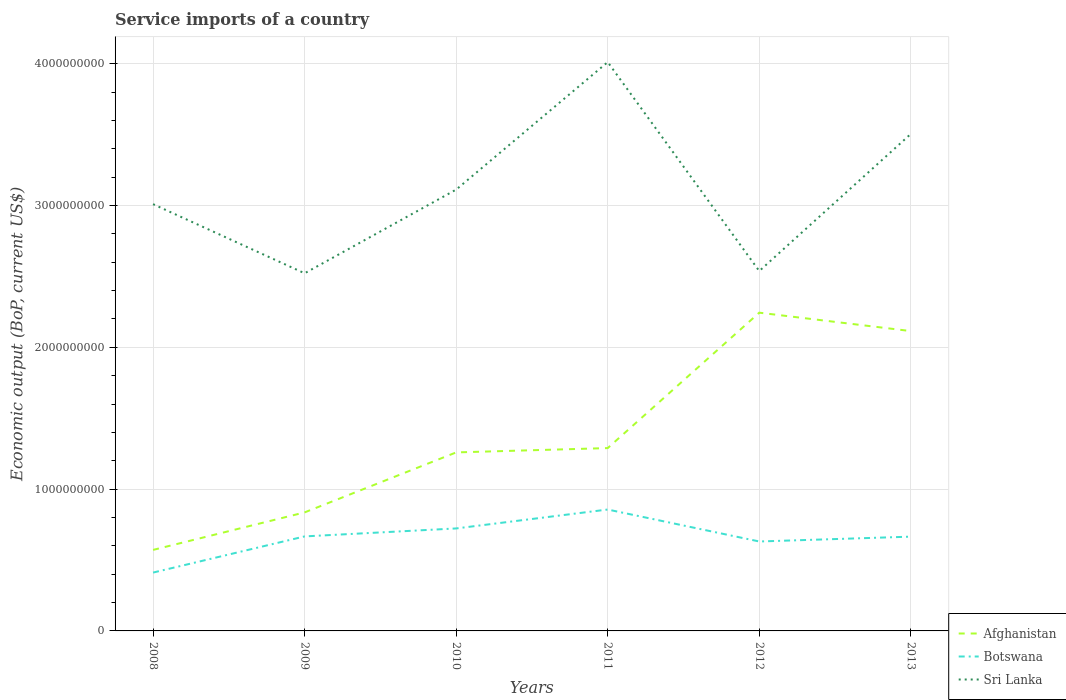How many different coloured lines are there?
Provide a short and direct response. 3. Across all years, what is the maximum service imports in Sri Lanka?
Provide a short and direct response. 2.52e+09. In which year was the service imports in Botswana maximum?
Your response must be concise. 2008. What is the total service imports in Botswana in the graph?
Give a very brief answer. 1.67e+06. What is the difference between the highest and the second highest service imports in Sri Lanka?
Ensure brevity in your answer.  1.49e+09. What is the difference between the highest and the lowest service imports in Botswana?
Ensure brevity in your answer.  4. How many lines are there?
Ensure brevity in your answer.  3. Does the graph contain grids?
Offer a terse response. Yes. How many legend labels are there?
Your answer should be compact. 3. How are the legend labels stacked?
Your response must be concise. Vertical. What is the title of the graph?
Offer a terse response. Service imports of a country. What is the label or title of the X-axis?
Provide a short and direct response. Years. What is the label or title of the Y-axis?
Your answer should be very brief. Economic output (BoP, current US$). What is the Economic output (BoP, current US$) of Afghanistan in 2008?
Offer a terse response. 5.71e+08. What is the Economic output (BoP, current US$) in Botswana in 2008?
Your response must be concise. 4.12e+08. What is the Economic output (BoP, current US$) of Sri Lanka in 2008?
Offer a terse response. 3.01e+09. What is the Economic output (BoP, current US$) of Afghanistan in 2009?
Make the answer very short. 8.36e+08. What is the Economic output (BoP, current US$) in Botswana in 2009?
Your answer should be compact. 6.67e+08. What is the Economic output (BoP, current US$) in Sri Lanka in 2009?
Keep it short and to the point. 2.52e+09. What is the Economic output (BoP, current US$) in Afghanistan in 2010?
Make the answer very short. 1.26e+09. What is the Economic output (BoP, current US$) in Botswana in 2010?
Your answer should be compact. 7.23e+08. What is the Economic output (BoP, current US$) in Sri Lanka in 2010?
Provide a succinct answer. 3.11e+09. What is the Economic output (BoP, current US$) in Afghanistan in 2011?
Ensure brevity in your answer.  1.29e+09. What is the Economic output (BoP, current US$) in Botswana in 2011?
Give a very brief answer. 8.56e+08. What is the Economic output (BoP, current US$) in Sri Lanka in 2011?
Make the answer very short. 4.01e+09. What is the Economic output (BoP, current US$) in Afghanistan in 2012?
Offer a terse response. 2.24e+09. What is the Economic output (BoP, current US$) of Botswana in 2012?
Keep it short and to the point. 6.31e+08. What is the Economic output (BoP, current US$) in Sri Lanka in 2012?
Give a very brief answer. 2.54e+09. What is the Economic output (BoP, current US$) of Afghanistan in 2013?
Your answer should be very brief. 2.11e+09. What is the Economic output (BoP, current US$) in Botswana in 2013?
Your response must be concise. 6.65e+08. What is the Economic output (BoP, current US$) in Sri Lanka in 2013?
Provide a short and direct response. 3.51e+09. Across all years, what is the maximum Economic output (BoP, current US$) in Afghanistan?
Provide a succinct answer. 2.24e+09. Across all years, what is the maximum Economic output (BoP, current US$) in Botswana?
Provide a succinct answer. 8.56e+08. Across all years, what is the maximum Economic output (BoP, current US$) of Sri Lanka?
Provide a succinct answer. 4.01e+09. Across all years, what is the minimum Economic output (BoP, current US$) of Afghanistan?
Give a very brief answer. 5.71e+08. Across all years, what is the minimum Economic output (BoP, current US$) in Botswana?
Your answer should be compact. 4.12e+08. Across all years, what is the minimum Economic output (BoP, current US$) of Sri Lanka?
Ensure brevity in your answer.  2.52e+09. What is the total Economic output (BoP, current US$) in Afghanistan in the graph?
Your answer should be compact. 8.32e+09. What is the total Economic output (BoP, current US$) of Botswana in the graph?
Ensure brevity in your answer.  3.95e+09. What is the total Economic output (BoP, current US$) in Sri Lanka in the graph?
Ensure brevity in your answer.  1.87e+1. What is the difference between the Economic output (BoP, current US$) of Afghanistan in 2008 and that in 2009?
Keep it short and to the point. -2.65e+08. What is the difference between the Economic output (BoP, current US$) in Botswana in 2008 and that in 2009?
Your answer should be very brief. -2.55e+08. What is the difference between the Economic output (BoP, current US$) in Sri Lanka in 2008 and that in 2009?
Make the answer very short. 4.87e+08. What is the difference between the Economic output (BoP, current US$) in Afghanistan in 2008 and that in 2010?
Give a very brief answer. -6.88e+08. What is the difference between the Economic output (BoP, current US$) of Botswana in 2008 and that in 2010?
Your response must be concise. -3.11e+08. What is the difference between the Economic output (BoP, current US$) of Sri Lanka in 2008 and that in 2010?
Give a very brief answer. -1.03e+08. What is the difference between the Economic output (BoP, current US$) in Afghanistan in 2008 and that in 2011?
Your answer should be very brief. -7.18e+08. What is the difference between the Economic output (BoP, current US$) of Botswana in 2008 and that in 2011?
Make the answer very short. -4.45e+08. What is the difference between the Economic output (BoP, current US$) of Sri Lanka in 2008 and that in 2011?
Provide a succinct answer. -1.00e+09. What is the difference between the Economic output (BoP, current US$) in Afghanistan in 2008 and that in 2012?
Provide a short and direct response. -1.67e+09. What is the difference between the Economic output (BoP, current US$) in Botswana in 2008 and that in 2012?
Your response must be concise. -2.19e+08. What is the difference between the Economic output (BoP, current US$) of Sri Lanka in 2008 and that in 2012?
Provide a short and direct response. 4.72e+08. What is the difference between the Economic output (BoP, current US$) in Afghanistan in 2008 and that in 2013?
Ensure brevity in your answer.  -1.54e+09. What is the difference between the Economic output (BoP, current US$) of Botswana in 2008 and that in 2013?
Provide a succinct answer. -2.53e+08. What is the difference between the Economic output (BoP, current US$) of Sri Lanka in 2008 and that in 2013?
Provide a succinct answer. -4.95e+08. What is the difference between the Economic output (BoP, current US$) of Afghanistan in 2009 and that in 2010?
Your response must be concise. -4.23e+08. What is the difference between the Economic output (BoP, current US$) of Botswana in 2009 and that in 2010?
Provide a succinct answer. -5.62e+07. What is the difference between the Economic output (BoP, current US$) of Sri Lanka in 2009 and that in 2010?
Offer a very short reply. -5.90e+08. What is the difference between the Economic output (BoP, current US$) in Afghanistan in 2009 and that in 2011?
Provide a short and direct response. -4.54e+08. What is the difference between the Economic output (BoP, current US$) of Botswana in 2009 and that in 2011?
Your answer should be very brief. -1.90e+08. What is the difference between the Economic output (BoP, current US$) in Sri Lanka in 2009 and that in 2011?
Provide a succinct answer. -1.49e+09. What is the difference between the Economic output (BoP, current US$) in Afghanistan in 2009 and that in 2012?
Provide a short and direct response. -1.41e+09. What is the difference between the Economic output (BoP, current US$) in Botswana in 2009 and that in 2012?
Your answer should be very brief. 3.58e+07. What is the difference between the Economic output (BoP, current US$) of Sri Lanka in 2009 and that in 2012?
Provide a succinct answer. -1.60e+07. What is the difference between the Economic output (BoP, current US$) of Afghanistan in 2009 and that in 2013?
Ensure brevity in your answer.  -1.28e+09. What is the difference between the Economic output (BoP, current US$) of Botswana in 2009 and that in 2013?
Offer a terse response. 1.67e+06. What is the difference between the Economic output (BoP, current US$) in Sri Lanka in 2009 and that in 2013?
Ensure brevity in your answer.  -9.83e+08. What is the difference between the Economic output (BoP, current US$) in Afghanistan in 2010 and that in 2011?
Offer a terse response. -3.05e+07. What is the difference between the Economic output (BoP, current US$) of Botswana in 2010 and that in 2011?
Offer a terse response. -1.33e+08. What is the difference between the Economic output (BoP, current US$) in Sri Lanka in 2010 and that in 2011?
Provide a succinct answer. -8.99e+08. What is the difference between the Economic output (BoP, current US$) in Afghanistan in 2010 and that in 2012?
Ensure brevity in your answer.  -9.86e+08. What is the difference between the Economic output (BoP, current US$) in Botswana in 2010 and that in 2012?
Make the answer very short. 9.21e+07. What is the difference between the Economic output (BoP, current US$) in Sri Lanka in 2010 and that in 2012?
Your response must be concise. 5.74e+08. What is the difference between the Economic output (BoP, current US$) in Afghanistan in 2010 and that in 2013?
Make the answer very short. -8.56e+08. What is the difference between the Economic output (BoP, current US$) of Botswana in 2010 and that in 2013?
Ensure brevity in your answer.  5.79e+07. What is the difference between the Economic output (BoP, current US$) of Sri Lanka in 2010 and that in 2013?
Ensure brevity in your answer.  -3.93e+08. What is the difference between the Economic output (BoP, current US$) in Afghanistan in 2011 and that in 2012?
Make the answer very short. -9.55e+08. What is the difference between the Economic output (BoP, current US$) in Botswana in 2011 and that in 2012?
Your answer should be very brief. 2.25e+08. What is the difference between the Economic output (BoP, current US$) in Sri Lanka in 2011 and that in 2012?
Offer a very short reply. 1.47e+09. What is the difference between the Economic output (BoP, current US$) of Afghanistan in 2011 and that in 2013?
Make the answer very short. -8.25e+08. What is the difference between the Economic output (BoP, current US$) in Botswana in 2011 and that in 2013?
Offer a terse response. 1.91e+08. What is the difference between the Economic output (BoP, current US$) of Sri Lanka in 2011 and that in 2013?
Provide a succinct answer. 5.07e+08. What is the difference between the Economic output (BoP, current US$) of Afghanistan in 2012 and that in 2013?
Make the answer very short. 1.30e+08. What is the difference between the Economic output (BoP, current US$) in Botswana in 2012 and that in 2013?
Your response must be concise. -3.42e+07. What is the difference between the Economic output (BoP, current US$) in Sri Lanka in 2012 and that in 2013?
Offer a terse response. -9.67e+08. What is the difference between the Economic output (BoP, current US$) of Afghanistan in 2008 and the Economic output (BoP, current US$) of Botswana in 2009?
Your answer should be compact. -9.52e+07. What is the difference between the Economic output (BoP, current US$) in Afghanistan in 2008 and the Economic output (BoP, current US$) in Sri Lanka in 2009?
Offer a terse response. -1.95e+09. What is the difference between the Economic output (BoP, current US$) in Botswana in 2008 and the Economic output (BoP, current US$) in Sri Lanka in 2009?
Provide a succinct answer. -2.11e+09. What is the difference between the Economic output (BoP, current US$) in Afghanistan in 2008 and the Economic output (BoP, current US$) in Botswana in 2010?
Give a very brief answer. -1.51e+08. What is the difference between the Economic output (BoP, current US$) in Afghanistan in 2008 and the Economic output (BoP, current US$) in Sri Lanka in 2010?
Make the answer very short. -2.54e+09. What is the difference between the Economic output (BoP, current US$) in Botswana in 2008 and the Economic output (BoP, current US$) in Sri Lanka in 2010?
Make the answer very short. -2.70e+09. What is the difference between the Economic output (BoP, current US$) of Afghanistan in 2008 and the Economic output (BoP, current US$) of Botswana in 2011?
Provide a succinct answer. -2.85e+08. What is the difference between the Economic output (BoP, current US$) in Afghanistan in 2008 and the Economic output (BoP, current US$) in Sri Lanka in 2011?
Offer a terse response. -3.44e+09. What is the difference between the Economic output (BoP, current US$) in Botswana in 2008 and the Economic output (BoP, current US$) in Sri Lanka in 2011?
Provide a short and direct response. -3.60e+09. What is the difference between the Economic output (BoP, current US$) in Afghanistan in 2008 and the Economic output (BoP, current US$) in Botswana in 2012?
Make the answer very short. -5.94e+07. What is the difference between the Economic output (BoP, current US$) of Afghanistan in 2008 and the Economic output (BoP, current US$) of Sri Lanka in 2012?
Offer a terse response. -1.97e+09. What is the difference between the Economic output (BoP, current US$) in Botswana in 2008 and the Economic output (BoP, current US$) in Sri Lanka in 2012?
Your answer should be very brief. -2.13e+09. What is the difference between the Economic output (BoP, current US$) of Afghanistan in 2008 and the Economic output (BoP, current US$) of Botswana in 2013?
Provide a short and direct response. -9.35e+07. What is the difference between the Economic output (BoP, current US$) of Afghanistan in 2008 and the Economic output (BoP, current US$) of Sri Lanka in 2013?
Your response must be concise. -2.93e+09. What is the difference between the Economic output (BoP, current US$) of Botswana in 2008 and the Economic output (BoP, current US$) of Sri Lanka in 2013?
Make the answer very short. -3.09e+09. What is the difference between the Economic output (BoP, current US$) in Afghanistan in 2009 and the Economic output (BoP, current US$) in Botswana in 2010?
Keep it short and to the point. 1.13e+08. What is the difference between the Economic output (BoP, current US$) of Afghanistan in 2009 and the Economic output (BoP, current US$) of Sri Lanka in 2010?
Ensure brevity in your answer.  -2.28e+09. What is the difference between the Economic output (BoP, current US$) of Botswana in 2009 and the Economic output (BoP, current US$) of Sri Lanka in 2010?
Your response must be concise. -2.45e+09. What is the difference between the Economic output (BoP, current US$) of Afghanistan in 2009 and the Economic output (BoP, current US$) of Botswana in 2011?
Provide a short and direct response. -2.02e+07. What is the difference between the Economic output (BoP, current US$) in Afghanistan in 2009 and the Economic output (BoP, current US$) in Sri Lanka in 2011?
Keep it short and to the point. -3.18e+09. What is the difference between the Economic output (BoP, current US$) in Botswana in 2009 and the Economic output (BoP, current US$) in Sri Lanka in 2011?
Make the answer very short. -3.35e+09. What is the difference between the Economic output (BoP, current US$) in Afghanistan in 2009 and the Economic output (BoP, current US$) in Botswana in 2012?
Offer a terse response. 2.05e+08. What is the difference between the Economic output (BoP, current US$) in Afghanistan in 2009 and the Economic output (BoP, current US$) in Sri Lanka in 2012?
Your answer should be very brief. -1.70e+09. What is the difference between the Economic output (BoP, current US$) of Botswana in 2009 and the Economic output (BoP, current US$) of Sri Lanka in 2012?
Give a very brief answer. -1.87e+09. What is the difference between the Economic output (BoP, current US$) of Afghanistan in 2009 and the Economic output (BoP, current US$) of Botswana in 2013?
Your answer should be compact. 1.71e+08. What is the difference between the Economic output (BoP, current US$) of Afghanistan in 2009 and the Economic output (BoP, current US$) of Sri Lanka in 2013?
Give a very brief answer. -2.67e+09. What is the difference between the Economic output (BoP, current US$) of Botswana in 2009 and the Economic output (BoP, current US$) of Sri Lanka in 2013?
Provide a short and direct response. -2.84e+09. What is the difference between the Economic output (BoP, current US$) in Afghanistan in 2010 and the Economic output (BoP, current US$) in Botswana in 2011?
Offer a very short reply. 4.03e+08. What is the difference between the Economic output (BoP, current US$) in Afghanistan in 2010 and the Economic output (BoP, current US$) in Sri Lanka in 2011?
Ensure brevity in your answer.  -2.75e+09. What is the difference between the Economic output (BoP, current US$) of Botswana in 2010 and the Economic output (BoP, current US$) of Sri Lanka in 2011?
Give a very brief answer. -3.29e+09. What is the difference between the Economic output (BoP, current US$) in Afghanistan in 2010 and the Economic output (BoP, current US$) in Botswana in 2012?
Make the answer very short. 6.28e+08. What is the difference between the Economic output (BoP, current US$) of Afghanistan in 2010 and the Economic output (BoP, current US$) of Sri Lanka in 2012?
Offer a terse response. -1.28e+09. What is the difference between the Economic output (BoP, current US$) in Botswana in 2010 and the Economic output (BoP, current US$) in Sri Lanka in 2012?
Make the answer very short. -1.82e+09. What is the difference between the Economic output (BoP, current US$) of Afghanistan in 2010 and the Economic output (BoP, current US$) of Botswana in 2013?
Your answer should be compact. 5.94e+08. What is the difference between the Economic output (BoP, current US$) in Afghanistan in 2010 and the Economic output (BoP, current US$) in Sri Lanka in 2013?
Offer a terse response. -2.25e+09. What is the difference between the Economic output (BoP, current US$) in Botswana in 2010 and the Economic output (BoP, current US$) in Sri Lanka in 2013?
Offer a terse response. -2.78e+09. What is the difference between the Economic output (BoP, current US$) in Afghanistan in 2011 and the Economic output (BoP, current US$) in Botswana in 2012?
Offer a terse response. 6.59e+08. What is the difference between the Economic output (BoP, current US$) in Afghanistan in 2011 and the Economic output (BoP, current US$) in Sri Lanka in 2012?
Provide a succinct answer. -1.25e+09. What is the difference between the Economic output (BoP, current US$) in Botswana in 2011 and the Economic output (BoP, current US$) in Sri Lanka in 2012?
Make the answer very short. -1.68e+09. What is the difference between the Economic output (BoP, current US$) of Afghanistan in 2011 and the Economic output (BoP, current US$) of Botswana in 2013?
Your response must be concise. 6.25e+08. What is the difference between the Economic output (BoP, current US$) in Afghanistan in 2011 and the Economic output (BoP, current US$) in Sri Lanka in 2013?
Make the answer very short. -2.22e+09. What is the difference between the Economic output (BoP, current US$) of Botswana in 2011 and the Economic output (BoP, current US$) of Sri Lanka in 2013?
Offer a very short reply. -2.65e+09. What is the difference between the Economic output (BoP, current US$) in Afghanistan in 2012 and the Economic output (BoP, current US$) in Botswana in 2013?
Offer a very short reply. 1.58e+09. What is the difference between the Economic output (BoP, current US$) of Afghanistan in 2012 and the Economic output (BoP, current US$) of Sri Lanka in 2013?
Your answer should be very brief. -1.26e+09. What is the difference between the Economic output (BoP, current US$) in Botswana in 2012 and the Economic output (BoP, current US$) in Sri Lanka in 2013?
Give a very brief answer. -2.87e+09. What is the average Economic output (BoP, current US$) in Afghanistan per year?
Your answer should be compact. 1.39e+09. What is the average Economic output (BoP, current US$) of Botswana per year?
Offer a very short reply. 6.59e+08. What is the average Economic output (BoP, current US$) of Sri Lanka per year?
Provide a short and direct response. 3.12e+09. In the year 2008, what is the difference between the Economic output (BoP, current US$) of Afghanistan and Economic output (BoP, current US$) of Botswana?
Your response must be concise. 1.60e+08. In the year 2008, what is the difference between the Economic output (BoP, current US$) of Afghanistan and Economic output (BoP, current US$) of Sri Lanka?
Give a very brief answer. -2.44e+09. In the year 2008, what is the difference between the Economic output (BoP, current US$) of Botswana and Economic output (BoP, current US$) of Sri Lanka?
Keep it short and to the point. -2.60e+09. In the year 2009, what is the difference between the Economic output (BoP, current US$) in Afghanistan and Economic output (BoP, current US$) in Botswana?
Provide a short and direct response. 1.69e+08. In the year 2009, what is the difference between the Economic output (BoP, current US$) in Afghanistan and Economic output (BoP, current US$) in Sri Lanka?
Ensure brevity in your answer.  -1.69e+09. In the year 2009, what is the difference between the Economic output (BoP, current US$) in Botswana and Economic output (BoP, current US$) in Sri Lanka?
Your answer should be very brief. -1.86e+09. In the year 2010, what is the difference between the Economic output (BoP, current US$) in Afghanistan and Economic output (BoP, current US$) in Botswana?
Provide a succinct answer. 5.36e+08. In the year 2010, what is the difference between the Economic output (BoP, current US$) in Afghanistan and Economic output (BoP, current US$) in Sri Lanka?
Provide a short and direct response. -1.85e+09. In the year 2010, what is the difference between the Economic output (BoP, current US$) in Botswana and Economic output (BoP, current US$) in Sri Lanka?
Give a very brief answer. -2.39e+09. In the year 2011, what is the difference between the Economic output (BoP, current US$) in Afghanistan and Economic output (BoP, current US$) in Botswana?
Offer a terse response. 4.33e+08. In the year 2011, what is the difference between the Economic output (BoP, current US$) in Afghanistan and Economic output (BoP, current US$) in Sri Lanka?
Provide a short and direct response. -2.72e+09. In the year 2011, what is the difference between the Economic output (BoP, current US$) in Botswana and Economic output (BoP, current US$) in Sri Lanka?
Keep it short and to the point. -3.16e+09. In the year 2012, what is the difference between the Economic output (BoP, current US$) in Afghanistan and Economic output (BoP, current US$) in Botswana?
Your answer should be very brief. 1.61e+09. In the year 2012, what is the difference between the Economic output (BoP, current US$) of Afghanistan and Economic output (BoP, current US$) of Sri Lanka?
Your response must be concise. -2.94e+08. In the year 2012, what is the difference between the Economic output (BoP, current US$) of Botswana and Economic output (BoP, current US$) of Sri Lanka?
Make the answer very short. -1.91e+09. In the year 2013, what is the difference between the Economic output (BoP, current US$) in Afghanistan and Economic output (BoP, current US$) in Botswana?
Your response must be concise. 1.45e+09. In the year 2013, what is the difference between the Economic output (BoP, current US$) of Afghanistan and Economic output (BoP, current US$) of Sri Lanka?
Your response must be concise. -1.39e+09. In the year 2013, what is the difference between the Economic output (BoP, current US$) in Botswana and Economic output (BoP, current US$) in Sri Lanka?
Your answer should be compact. -2.84e+09. What is the ratio of the Economic output (BoP, current US$) in Afghanistan in 2008 to that in 2009?
Offer a terse response. 0.68. What is the ratio of the Economic output (BoP, current US$) of Botswana in 2008 to that in 2009?
Your response must be concise. 0.62. What is the ratio of the Economic output (BoP, current US$) of Sri Lanka in 2008 to that in 2009?
Give a very brief answer. 1.19. What is the ratio of the Economic output (BoP, current US$) of Afghanistan in 2008 to that in 2010?
Offer a very short reply. 0.45. What is the ratio of the Economic output (BoP, current US$) in Botswana in 2008 to that in 2010?
Provide a short and direct response. 0.57. What is the ratio of the Economic output (BoP, current US$) of Sri Lanka in 2008 to that in 2010?
Offer a very short reply. 0.97. What is the ratio of the Economic output (BoP, current US$) in Afghanistan in 2008 to that in 2011?
Offer a very short reply. 0.44. What is the ratio of the Economic output (BoP, current US$) in Botswana in 2008 to that in 2011?
Your answer should be very brief. 0.48. What is the ratio of the Economic output (BoP, current US$) in Sri Lanka in 2008 to that in 2011?
Ensure brevity in your answer.  0.75. What is the ratio of the Economic output (BoP, current US$) of Afghanistan in 2008 to that in 2012?
Your response must be concise. 0.25. What is the ratio of the Economic output (BoP, current US$) in Botswana in 2008 to that in 2012?
Make the answer very short. 0.65. What is the ratio of the Economic output (BoP, current US$) of Sri Lanka in 2008 to that in 2012?
Keep it short and to the point. 1.19. What is the ratio of the Economic output (BoP, current US$) in Afghanistan in 2008 to that in 2013?
Provide a succinct answer. 0.27. What is the ratio of the Economic output (BoP, current US$) of Botswana in 2008 to that in 2013?
Ensure brevity in your answer.  0.62. What is the ratio of the Economic output (BoP, current US$) in Sri Lanka in 2008 to that in 2013?
Offer a very short reply. 0.86. What is the ratio of the Economic output (BoP, current US$) in Afghanistan in 2009 to that in 2010?
Make the answer very short. 0.66. What is the ratio of the Economic output (BoP, current US$) in Botswana in 2009 to that in 2010?
Provide a short and direct response. 0.92. What is the ratio of the Economic output (BoP, current US$) in Sri Lanka in 2009 to that in 2010?
Provide a succinct answer. 0.81. What is the ratio of the Economic output (BoP, current US$) of Afghanistan in 2009 to that in 2011?
Provide a succinct answer. 0.65. What is the ratio of the Economic output (BoP, current US$) of Botswana in 2009 to that in 2011?
Provide a succinct answer. 0.78. What is the ratio of the Economic output (BoP, current US$) of Sri Lanka in 2009 to that in 2011?
Keep it short and to the point. 0.63. What is the ratio of the Economic output (BoP, current US$) of Afghanistan in 2009 to that in 2012?
Your response must be concise. 0.37. What is the ratio of the Economic output (BoP, current US$) in Botswana in 2009 to that in 2012?
Your answer should be very brief. 1.06. What is the ratio of the Economic output (BoP, current US$) of Afghanistan in 2009 to that in 2013?
Offer a very short reply. 0.4. What is the ratio of the Economic output (BoP, current US$) in Botswana in 2009 to that in 2013?
Your answer should be very brief. 1. What is the ratio of the Economic output (BoP, current US$) in Sri Lanka in 2009 to that in 2013?
Provide a short and direct response. 0.72. What is the ratio of the Economic output (BoP, current US$) in Afghanistan in 2010 to that in 2011?
Keep it short and to the point. 0.98. What is the ratio of the Economic output (BoP, current US$) of Botswana in 2010 to that in 2011?
Provide a succinct answer. 0.84. What is the ratio of the Economic output (BoP, current US$) in Sri Lanka in 2010 to that in 2011?
Ensure brevity in your answer.  0.78. What is the ratio of the Economic output (BoP, current US$) in Afghanistan in 2010 to that in 2012?
Ensure brevity in your answer.  0.56. What is the ratio of the Economic output (BoP, current US$) in Botswana in 2010 to that in 2012?
Provide a succinct answer. 1.15. What is the ratio of the Economic output (BoP, current US$) of Sri Lanka in 2010 to that in 2012?
Provide a short and direct response. 1.23. What is the ratio of the Economic output (BoP, current US$) of Afghanistan in 2010 to that in 2013?
Provide a short and direct response. 0.6. What is the ratio of the Economic output (BoP, current US$) of Botswana in 2010 to that in 2013?
Provide a short and direct response. 1.09. What is the ratio of the Economic output (BoP, current US$) of Sri Lanka in 2010 to that in 2013?
Give a very brief answer. 0.89. What is the ratio of the Economic output (BoP, current US$) in Afghanistan in 2011 to that in 2012?
Keep it short and to the point. 0.57. What is the ratio of the Economic output (BoP, current US$) of Botswana in 2011 to that in 2012?
Your response must be concise. 1.36. What is the ratio of the Economic output (BoP, current US$) of Sri Lanka in 2011 to that in 2012?
Keep it short and to the point. 1.58. What is the ratio of the Economic output (BoP, current US$) in Afghanistan in 2011 to that in 2013?
Ensure brevity in your answer.  0.61. What is the ratio of the Economic output (BoP, current US$) of Botswana in 2011 to that in 2013?
Provide a short and direct response. 1.29. What is the ratio of the Economic output (BoP, current US$) of Sri Lanka in 2011 to that in 2013?
Make the answer very short. 1.14. What is the ratio of the Economic output (BoP, current US$) in Afghanistan in 2012 to that in 2013?
Offer a very short reply. 1.06. What is the ratio of the Economic output (BoP, current US$) in Botswana in 2012 to that in 2013?
Make the answer very short. 0.95. What is the ratio of the Economic output (BoP, current US$) in Sri Lanka in 2012 to that in 2013?
Make the answer very short. 0.72. What is the difference between the highest and the second highest Economic output (BoP, current US$) of Afghanistan?
Your answer should be very brief. 1.30e+08. What is the difference between the highest and the second highest Economic output (BoP, current US$) of Botswana?
Ensure brevity in your answer.  1.33e+08. What is the difference between the highest and the second highest Economic output (BoP, current US$) in Sri Lanka?
Your response must be concise. 5.07e+08. What is the difference between the highest and the lowest Economic output (BoP, current US$) of Afghanistan?
Ensure brevity in your answer.  1.67e+09. What is the difference between the highest and the lowest Economic output (BoP, current US$) in Botswana?
Your answer should be very brief. 4.45e+08. What is the difference between the highest and the lowest Economic output (BoP, current US$) of Sri Lanka?
Keep it short and to the point. 1.49e+09. 